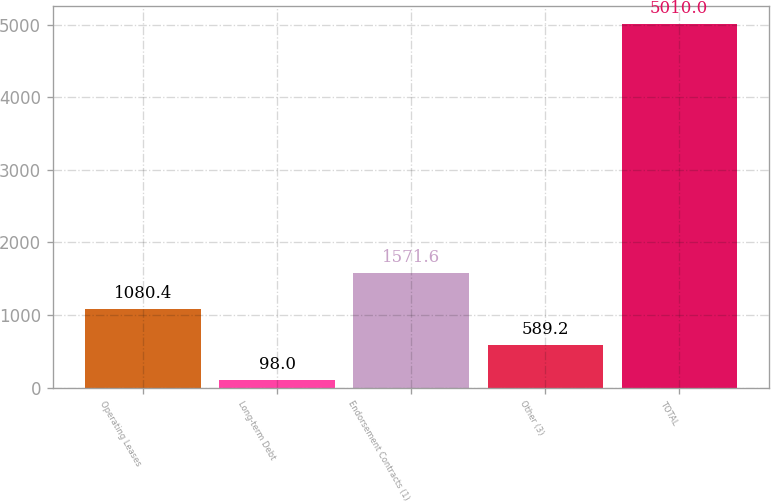<chart> <loc_0><loc_0><loc_500><loc_500><bar_chart><fcel>Operating Leases<fcel>Long-term Debt<fcel>Endorsement Contracts (1)<fcel>Other (3)<fcel>TOTAL<nl><fcel>1080.4<fcel>98<fcel>1571.6<fcel>589.2<fcel>5010<nl></chart> 